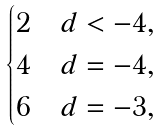Convert formula to latex. <formula><loc_0><loc_0><loc_500><loc_500>\begin{cases} 2 & d < - 4 , \\ 4 & d = - 4 , \\ 6 & d = - 3 , \end{cases}</formula> 